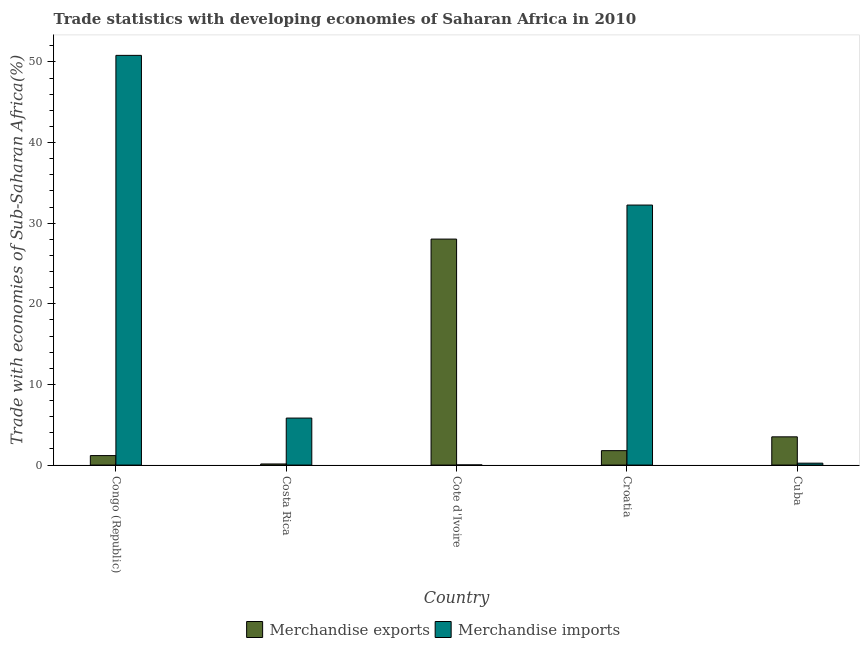Are the number of bars per tick equal to the number of legend labels?
Offer a very short reply. Yes. Are the number of bars on each tick of the X-axis equal?
Your answer should be very brief. Yes. How many bars are there on the 3rd tick from the left?
Ensure brevity in your answer.  2. What is the label of the 5th group of bars from the left?
Make the answer very short. Cuba. What is the merchandise imports in Costa Rica?
Make the answer very short. 5.83. Across all countries, what is the maximum merchandise imports?
Offer a very short reply. 50.81. Across all countries, what is the minimum merchandise exports?
Offer a terse response. 0.14. In which country was the merchandise imports maximum?
Keep it short and to the point. Congo (Republic). In which country was the merchandise imports minimum?
Ensure brevity in your answer.  Cote d'Ivoire. What is the total merchandise exports in the graph?
Provide a succinct answer. 34.63. What is the difference between the merchandise exports in Croatia and that in Cuba?
Give a very brief answer. -1.71. What is the difference between the merchandise imports in Congo (Republic) and the merchandise exports in Croatia?
Ensure brevity in your answer.  49.02. What is the average merchandise exports per country?
Your response must be concise. 6.93. What is the difference between the merchandise imports and merchandise exports in Costa Rica?
Provide a short and direct response. 5.69. In how many countries, is the merchandise imports greater than 6 %?
Make the answer very short. 2. What is the ratio of the merchandise imports in Cote d'Ivoire to that in Croatia?
Your answer should be compact. 0. Is the merchandise imports in Congo (Republic) less than that in Cote d'Ivoire?
Provide a succinct answer. No. Is the difference between the merchandise exports in Costa Rica and Cote d'Ivoire greater than the difference between the merchandise imports in Costa Rica and Cote d'Ivoire?
Your response must be concise. No. What is the difference between the highest and the second highest merchandise imports?
Your response must be concise. 18.57. What is the difference between the highest and the lowest merchandise imports?
Your answer should be compact. 50.79. What does the 1st bar from the right in Costa Rica represents?
Make the answer very short. Merchandise imports. How many bars are there?
Offer a very short reply. 10. Are all the bars in the graph horizontal?
Make the answer very short. No. How many countries are there in the graph?
Give a very brief answer. 5. What is the difference between two consecutive major ticks on the Y-axis?
Your answer should be compact. 10. Does the graph contain grids?
Your response must be concise. No. Where does the legend appear in the graph?
Make the answer very short. Bottom center. What is the title of the graph?
Make the answer very short. Trade statistics with developing economies of Saharan Africa in 2010. What is the label or title of the Y-axis?
Provide a short and direct response. Trade with economies of Sub-Saharan Africa(%). What is the Trade with economies of Sub-Saharan Africa(%) in Merchandise exports in Congo (Republic)?
Offer a very short reply. 1.18. What is the Trade with economies of Sub-Saharan Africa(%) in Merchandise imports in Congo (Republic)?
Your answer should be compact. 50.81. What is the Trade with economies of Sub-Saharan Africa(%) in Merchandise exports in Costa Rica?
Provide a short and direct response. 0.14. What is the Trade with economies of Sub-Saharan Africa(%) in Merchandise imports in Costa Rica?
Give a very brief answer. 5.83. What is the Trade with economies of Sub-Saharan Africa(%) in Merchandise exports in Cote d'Ivoire?
Provide a short and direct response. 28.03. What is the Trade with economies of Sub-Saharan Africa(%) in Merchandise imports in Cote d'Ivoire?
Your answer should be very brief. 0.02. What is the Trade with economies of Sub-Saharan Africa(%) of Merchandise exports in Croatia?
Your answer should be compact. 1.79. What is the Trade with economies of Sub-Saharan Africa(%) in Merchandise imports in Croatia?
Ensure brevity in your answer.  32.25. What is the Trade with economies of Sub-Saharan Africa(%) in Merchandise exports in Cuba?
Give a very brief answer. 3.5. What is the Trade with economies of Sub-Saharan Africa(%) in Merchandise imports in Cuba?
Give a very brief answer. 0.24. Across all countries, what is the maximum Trade with economies of Sub-Saharan Africa(%) in Merchandise exports?
Give a very brief answer. 28.03. Across all countries, what is the maximum Trade with economies of Sub-Saharan Africa(%) of Merchandise imports?
Provide a short and direct response. 50.81. Across all countries, what is the minimum Trade with economies of Sub-Saharan Africa(%) in Merchandise exports?
Your response must be concise. 0.14. Across all countries, what is the minimum Trade with economies of Sub-Saharan Africa(%) in Merchandise imports?
Ensure brevity in your answer.  0.02. What is the total Trade with economies of Sub-Saharan Africa(%) in Merchandise exports in the graph?
Make the answer very short. 34.63. What is the total Trade with economies of Sub-Saharan Africa(%) of Merchandise imports in the graph?
Give a very brief answer. 89.15. What is the difference between the Trade with economies of Sub-Saharan Africa(%) in Merchandise exports in Congo (Republic) and that in Costa Rica?
Ensure brevity in your answer.  1.04. What is the difference between the Trade with economies of Sub-Saharan Africa(%) of Merchandise imports in Congo (Republic) and that in Costa Rica?
Provide a succinct answer. 44.98. What is the difference between the Trade with economies of Sub-Saharan Africa(%) of Merchandise exports in Congo (Republic) and that in Cote d'Ivoire?
Your answer should be very brief. -26.85. What is the difference between the Trade with economies of Sub-Saharan Africa(%) in Merchandise imports in Congo (Republic) and that in Cote d'Ivoire?
Your response must be concise. 50.79. What is the difference between the Trade with economies of Sub-Saharan Africa(%) in Merchandise exports in Congo (Republic) and that in Croatia?
Your answer should be very brief. -0.61. What is the difference between the Trade with economies of Sub-Saharan Africa(%) of Merchandise imports in Congo (Republic) and that in Croatia?
Provide a succinct answer. 18.57. What is the difference between the Trade with economies of Sub-Saharan Africa(%) of Merchandise exports in Congo (Republic) and that in Cuba?
Offer a terse response. -2.33. What is the difference between the Trade with economies of Sub-Saharan Africa(%) of Merchandise imports in Congo (Republic) and that in Cuba?
Your answer should be compact. 50.58. What is the difference between the Trade with economies of Sub-Saharan Africa(%) in Merchandise exports in Costa Rica and that in Cote d'Ivoire?
Your answer should be very brief. -27.89. What is the difference between the Trade with economies of Sub-Saharan Africa(%) in Merchandise imports in Costa Rica and that in Cote d'Ivoire?
Your answer should be very brief. 5.81. What is the difference between the Trade with economies of Sub-Saharan Africa(%) in Merchandise exports in Costa Rica and that in Croatia?
Your response must be concise. -1.65. What is the difference between the Trade with economies of Sub-Saharan Africa(%) of Merchandise imports in Costa Rica and that in Croatia?
Provide a short and direct response. -26.42. What is the difference between the Trade with economies of Sub-Saharan Africa(%) in Merchandise exports in Costa Rica and that in Cuba?
Ensure brevity in your answer.  -3.36. What is the difference between the Trade with economies of Sub-Saharan Africa(%) in Merchandise imports in Costa Rica and that in Cuba?
Your response must be concise. 5.59. What is the difference between the Trade with economies of Sub-Saharan Africa(%) in Merchandise exports in Cote d'Ivoire and that in Croatia?
Keep it short and to the point. 26.24. What is the difference between the Trade with economies of Sub-Saharan Africa(%) of Merchandise imports in Cote d'Ivoire and that in Croatia?
Offer a very short reply. -32.23. What is the difference between the Trade with economies of Sub-Saharan Africa(%) in Merchandise exports in Cote d'Ivoire and that in Cuba?
Your answer should be very brief. 24.52. What is the difference between the Trade with economies of Sub-Saharan Africa(%) in Merchandise imports in Cote d'Ivoire and that in Cuba?
Give a very brief answer. -0.22. What is the difference between the Trade with economies of Sub-Saharan Africa(%) in Merchandise exports in Croatia and that in Cuba?
Offer a terse response. -1.71. What is the difference between the Trade with economies of Sub-Saharan Africa(%) of Merchandise imports in Croatia and that in Cuba?
Give a very brief answer. 32.01. What is the difference between the Trade with economies of Sub-Saharan Africa(%) in Merchandise exports in Congo (Republic) and the Trade with economies of Sub-Saharan Africa(%) in Merchandise imports in Costa Rica?
Make the answer very short. -4.65. What is the difference between the Trade with economies of Sub-Saharan Africa(%) in Merchandise exports in Congo (Republic) and the Trade with economies of Sub-Saharan Africa(%) in Merchandise imports in Cote d'Ivoire?
Offer a terse response. 1.16. What is the difference between the Trade with economies of Sub-Saharan Africa(%) in Merchandise exports in Congo (Republic) and the Trade with economies of Sub-Saharan Africa(%) in Merchandise imports in Croatia?
Your response must be concise. -31.07. What is the difference between the Trade with economies of Sub-Saharan Africa(%) of Merchandise exports in Congo (Republic) and the Trade with economies of Sub-Saharan Africa(%) of Merchandise imports in Cuba?
Give a very brief answer. 0.94. What is the difference between the Trade with economies of Sub-Saharan Africa(%) in Merchandise exports in Costa Rica and the Trade with economies of Sub-Saharan Africa(%) in Merchandise imports in Cote d'Ivoire?
Keep it short and to the point. 0.12. What is the difference between the Trade with economies of Sub-Saharan Africa(%) in Merchandise exports in Costa Rica and the Trade with economies of Sub-Saharan Africa(%) in Merchandise imports in Croatia?
Offer a terse response. -32.11. What is the difference between the Trade with economies of Sub-Saharan Africa(%) of Merchandise exports in Costa Rica and the Trade with economies of Sub-Saharan Africa(%) of Merchandise imports in Cuba?
Provide a short and direct response. -0.1. What is the difference between the Trade with economies of Sub-Saharan Africa(%) in Merchandise exports in Cote d'Ivoire and the Trade with economies of Sub-Saharan Africa(%) in Merchandise imports in Croatia?
Provide a succinct answer. -4.22. What is the difference between the Trade with economies of Sub-Saharan Africa(%) in Merchandise exports in Cote d'Ivoire and the Trade with economies of Sub-Saharan Africa(%) in Merchandise imports in Cuba?
Your response must be concise. 27.79. What is the difference between the Trade with economies of Sub-Saharan Africa(%) of Merchandise exports in Croatia and the Trade with economies of Sub-Saharan Africa(%) of Merchandise imports in Cuba?
Keep it short and to the point. 1.55. What is the average Trade with economies of Sub-Saharan Africa(%) in Merchandise exports per country?
Your answer should be compact. 6.93. What is the average Trade with economies of Sub-Saharan Africa(%) in Merchandise imports per country?
Offer a terse response. 17.83. What is the difference between the Trade with economies of Sub-Saharan Africa(%) of Merchandise exports and Trade with economies of Sub-Saharan Africa(%) of Merchandise imports in Congo (Republic)?
Offer a terse response. -49.64. What is the difference between the Trade with economies of Sub-Saharan Africa(%) in Merchandise exports and Trade with economies of Sub-Saharan Africa(%) in Merchandise imports in Costa Rica?
Your answer should be compact. -5.69. What is the difference between the Trade with economies of Sub-Saharan Africa(%) in Merchandise exports and Trade with economies of Sub-Saharan Africa(%) in Merchandise imports in Cote d'Ivoire?
Provide a succinct answer. 28.01. What is the difference between the Trade with economies of Sub-Saharan Africa(%) in Merchandise exports and Trade with economies of Sub-Saharan Africa(%) in Merchandise imports in Croatia?
Provide a succinct answer. -30.46. What is the difference between the Trade with economies of Sub-Saharan Africa(%) in Merchandise exports and Trade with economies of Sub-Saharan Africa(%) in Merchandise imports in Cuba?
Keep it short and to the point. 3.26. What is the ratio of the Trade with economies of Sub-Saharan Africa(%) of Merchandise exports in Congo (Republic) to that in Costa Rica?
Keep it short and to the point. 8.48. What is the ratio of the Trade with economies of Sub-Saharan Africa(%) in Merchandise imports in Congo (Republic) to that in Costa Rica?
Ensure brevity in your answer.  8.72. What is the ratio of the Trade with economies of Sub-Saharan Africa(%) of Merchandise exports in Congo (Republic) to that in Cote d'Ivoire?
Give a very brief answer. 0.04. What is the ratio of the Trade with economies of Sub-Saharan Africa(%) in Merchandise imports in Congo (Republic) to that in Cote d'Ivoire?
Your response must be concise. 2761.16. What is the ratio of the Trade with economies of Sub-Saharan Africa(%) in Merchandise exports in Congo (Republic) to that in Croatia?
Offer a terse response. 0.66. What is the ratio of the Trade with economies of Sub-Saharan Africa(%) of Merchandise imports in Congo (Republic) to that in Croatia?
Your response must be concise. 1.58. What is the ratio of the Trade with economies of Sub-Saharan Africa(%) of Merchandise exports in Congo (Republic) to that in Cuba?
Ensure brevity in your answer.  0.34. What is the ratio of the Trade with economies of Sub-Saharan Africa(%) in Merchandise imports in Congo (Republic) to that in Cuba?
Provide a short and direct response. 213.88. What is the ratio of the Trade with economies of Sub-Saharan Africa(%) in Merchandise exports in Costa Rica to that in Cote d'Ivoire?
Provide a short and direct response. 0. What is the ratio of the Trade with economies of Sub-Saharan Africa(%) of Merchandise imports in Costa Rica to that in Cote d'Ivoire?
Your answer should be very brief. 316.75. What is the ratio of the Trade with economies of Sub-Saharan Africa(%) of Merchandise exports in Costa Rica to that in Croatia?
Provide a short and direct response. 0.08. What is the ratio of the Trade with economies of Sub-Saharan Africa(%) of Merchandise imports in Costa Rica to that in Croatia?
Provide a succinct answer. 0.18. What is the ratio of the Trade with economies of Sub-Saharan Africa(%) in Merchandise exports in Costa Rica to that in Cuba?
Your answer should be very brief. 0.04. What is the ratio of the Trade with economies of Sub-Saharan Africa(%) of Merchandise imports in Costa Rica to that in Cuba?
Your answer should be compact. 24.54. What is the ratio of the Trade with economies of Sub-Saharan Africa(%) of Merchandise exports in Cote d'Ivoire to that in Croatia?
Ensure brevity in your answer.  15.67. What is the ratio of the Trade with economies of Sub-Saharan Africa(%) in Merchandise imports in Cote d'Ivoire to that in Croatia?
Your answer should be compact. 0. What is the ratio of the Trade with economies of Sub-Saharan Africa(%) of Merchandise exports in Cote d'Ivoire to that in Cuba?
Provide a short and direct response. 8. What is the ratio of the Trade with economies of Sub-Saharan Africa(%) in Merchandise imports in Cote d'Ivoire to that in Cuba?
Offer a terse response. 0.08. What is the ratio of the Trade with economies of Sub-Saharan Africa(%) in Merchandise exports in Croatia to that in Cuba?
Provide a succinct answer. 0.51. What is the ratio of the Trade with economies of Sub-Saharan Africa(%) in Merchandise imports in Croatia to that in Cuba?
Offer a very short reply. 135.73. What is the difference between the highest and the second highest Trade with economies of Sub-Saharan Africa(%) in Merchandise exports?
Your answer should be very brief. 24.52. What is the difference between the highest and the second highest Trade with economies of Sub-Saharan Africa(%) of Merchandise imports?
Give a very brief answer. 18.57. What is the difference between the highest and the lowest Trade with economies of Sub-Saharan Africa(%) in Merchandise exports?
Your response must be concise. 27.89. What is the difference between the highest and the lowest Trade with economies of Sub-Saharan Africa(%) of Merchandise imports?
Your answer should be very brief. 50.79. 